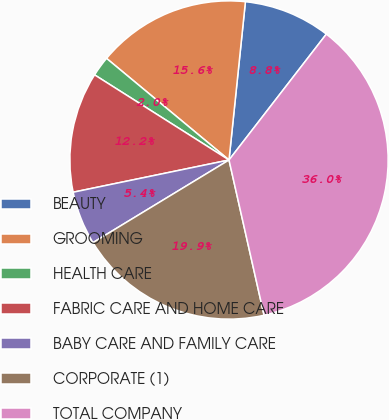Convert chart. <chart><loc_0><loc_0><loc_500><loc_500><pie_chart><fcel>BEAUTY<fcel>GROOMING<fcel>HEALTH CARE<fcel>FABRIC CARE AND HOME CARE<fcel>BABY CARE AND FAMILY CARE<fcel>CORPORATE (1)<fcel>TOTAL COMPANY<nl><fcel>8.83%<fcel>15.62%<fcel>2.04%<fcel>12.23%<fcel>5.44%<fcel>19.85%<fcel>35.99%<nl></chart> 